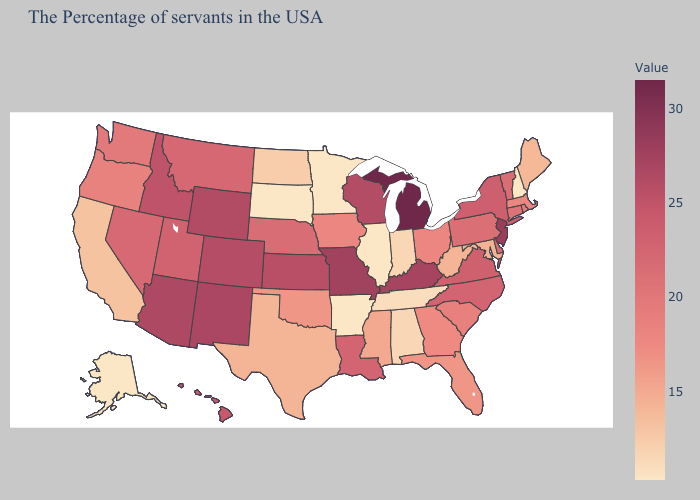Does Vermont have a higher value than Indiana?
Quick response, please. Yes. Among the states that border South Dakota , which have the lowest value?
Concise answer only. Minnesota. Which states have the lowest value in the Northeast?
Short answer required. New Hampshire. Which states have the lowest value in the USA?
Quick response, please. New Hampshire, Illinois, Arkansas, Minnesota, South Dakota, Alaska. Which states have the lowest value in the USA?
Quick response, please. New Hampshire, Illinois, Arkansas, Minnesota, South Dakota, Alaska. Which states have the highest value in the USA?
Give a very brief answer. Michigan. 